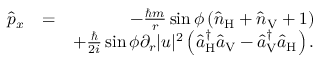<formula> <loc_0><loc_0><loc_500><loc_500>\begin{array} { r l r } { \hat { p } _ { x } } & { = } & { - \frac { \hbar { m } } { r } \sin \phi \left ( \hat { n } _ { H } + \hat { n } _ { V } + 1 \right ) } \\ & { + \frac { } { 2 i } \sin \phi \partial _ { r } | u | ^ { 2 } \left ( \hat { a } _ { H } ^ { \dagger } \hat { a } _ { V } - \hat { a } _ { V } ^ { \dagger } \hat { a } _ { H } \right ) . } \end{array}</formula> 